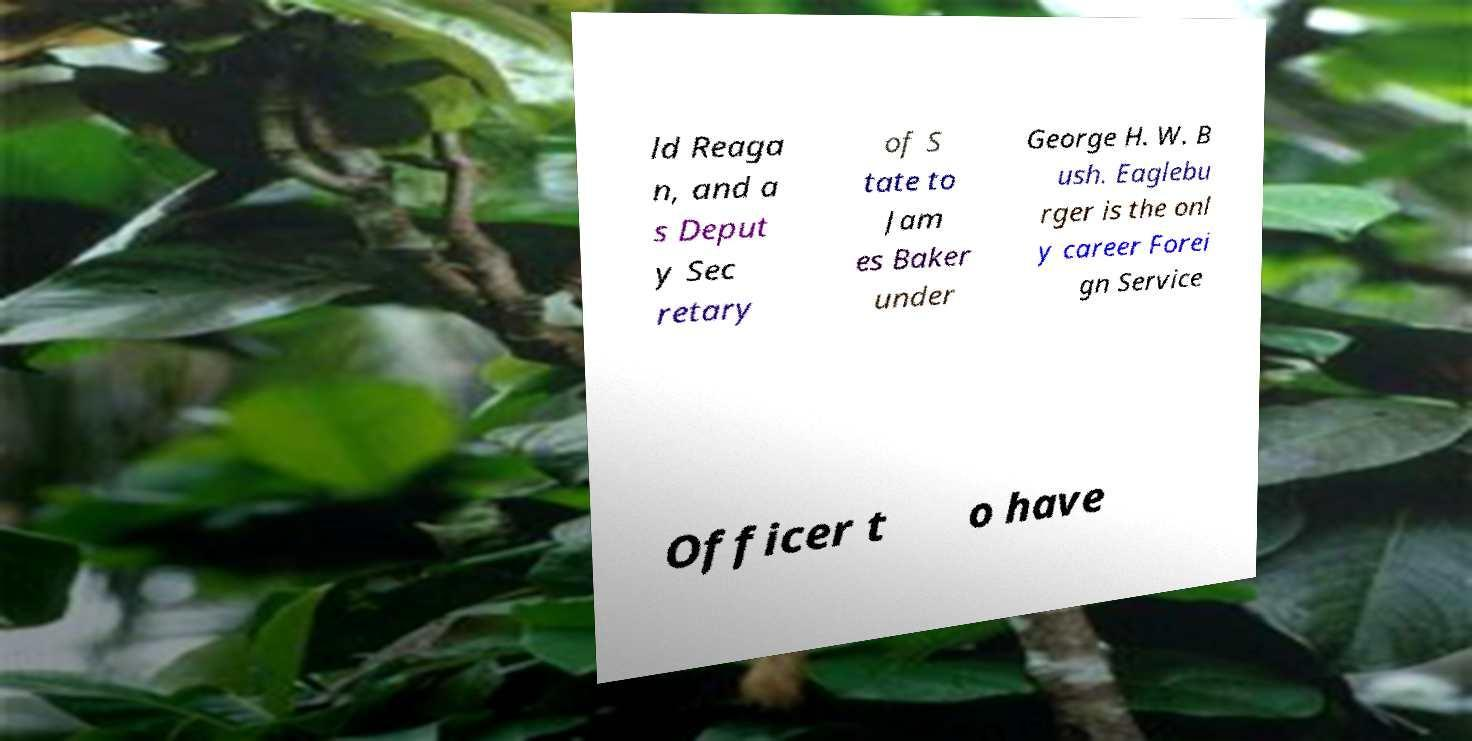Please identify and transcribe the text found in this image. ld Reaga n, and a s Deput y Sec retary of S tate to Jam es Baker under George H. W. B ush. Eaglebu rger is the onl y career Forei gn Service Officer t o have 